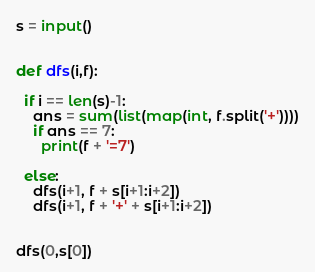<code> <loc_0><loc_0><loc_500><loc_500><_Python_>s = input()


def dfs(i,f):
  
  if i == len(s)-1:
    ans = sum(list(map(int, f.split('+'))))
    if ans == 7:
      print(f + '=7')
    
  else:
    dfs(i+1, f + s[i+1:i+2])
    dfs(i+1, f + '+' + s[i+1:i+2])
      

dfs(0,s[0])</code> 